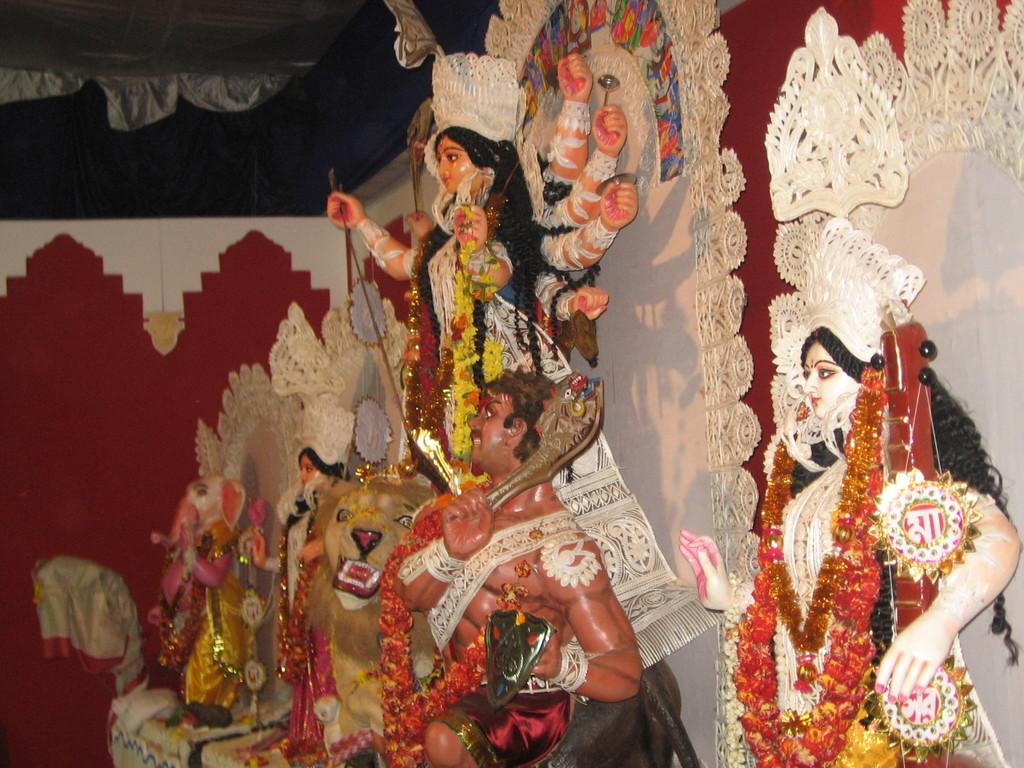What type of figures are depicted in the image? There are statues of gods and goddesses in the image. How are the statues adorned? The statues are decorated with clothes and garlands. What else can be seen in the image besides the statues? There are tents visible on the top of the image. What type of leaf is being used as a tablecloth for the grandmother in the image? There is no grandmother or leaf present in the image; it features statues of gods and goddesses with decorations. 